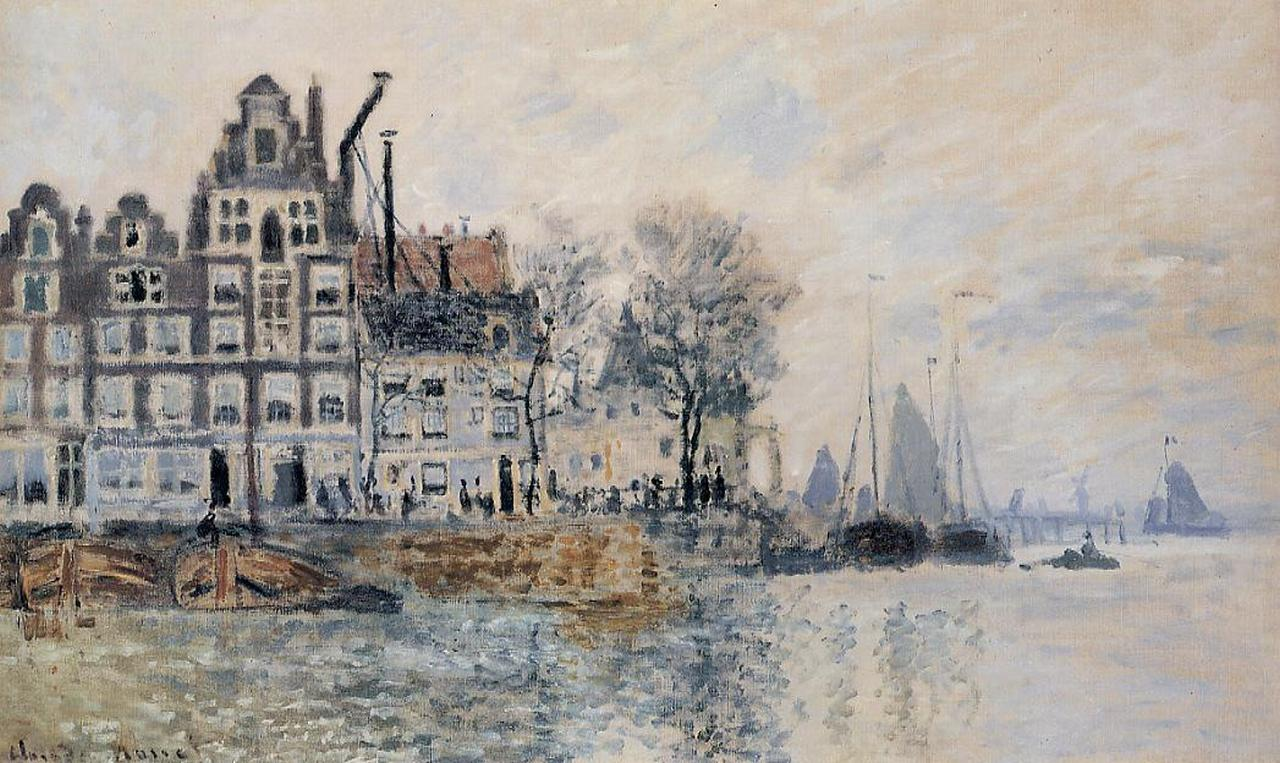Imagine yourself as one of the people in the painting. Describe what you see and feel. As I stand by the river, I can feel the cool, moist air against my skin, a gentle breeze carrying the scent of the water and faint hints of distant rain. The boats are gently bobbing, their reflections rippling softly in the calm water. The city around me is alive yet peaceful, each building telling a story through its weathered facade and intricate architecture. I see fellow townsfolk going about their day, mingling with the subtle murmur of conversation and light footsteps on the cobblestone streets. The serene, overcast sky above casts a rosy hue, creating a sense of timelessness and reflection. The entire scene envelops me in a sense of tranquil nostalgia and quiet dignity. What do you think the history behind these buildings is? Create a detailed narrative. These buildings, standing tall and proud by the river, have witnessed the ebb and flow of history for centuries. Originally constructed during the height of the Renaissance, these structures have housed generations of families, traders, and artisans. Their intricate facades tell tales of prosperity and innovation, with each gable and window frame meticulously designed to showcase the architectural prowess of the era. During the Industrial Revolution, these buildings became central to a bustling hub of commerce, with boats arriving from distant lands, laden with goods and treasures. The riverfront, now tranquil, once bustled with merchants haggling over the price of spices, textiles, and precious metals. Over the years, these homes have seen the joys of festivals and the trials of wars, their walls reverberating with the laughter of children and the solemn whispers of history. Though the city has modernized, these buildings stand as steadfast guardians of the past, each brick and beam a testament to the legacy of those who once lived and thrived here. If the trees in the painting could talk, what stories would they tell? The trees, standing quietly by the river, would whisper stories of resilience and change. They have witnessed the seasons come and go, their leaves dancing through springs of renewal and autumns of reflection. They have seen children playing at their roots, lovers carving initials into their bark, and families seeking shade under their canopies during market days. With age, these trees have grown wiser, their branches stretching towards the sky as silent witnesses to the city’s transformations. They would speak of a time when the river teemed with boats bearing exotic wares, of festive nights illuminated by lanterns and laughter, of quieter moments when the city seemed to pause and breathe. Through wars, prosperity, and everything in-between, these trees have remained, their steadfast presence offering a sense of continuity and peace to the ever-changing lives around them. Imagine this scene in a completely different environment. What changes would you observe? Imagine this cityscape transplanted to a tropical seaside village. The river would transform into a crystal-clear lagoon, its waters shimmering with turquoise hues under the bright sun. Palm trees would replace the sparsely foliaged trees, their fronds swaying gently in the warm breeze. The European-style buildings would morph into colorful, thatched-roof huts and bungalows, their facades adorned with vibrant murals and flowers. The boats would become sleek, wooden canoes and small fishing vessels, painted in lively colors and adorned with ornate carvings. The sky, no longer overcast, would be a brilliant cerulean blue, dotted with fluffy, white clouds. The atmosphere would feel more vibrant and alive, with the sounds of tropical birds and the distant hum of music from beachside cafes. The sense of tranquility would remain, but it would be infused with the warmth and vitality of a tropical paradise, creating a harmonious blend of serenity and exuberance. 